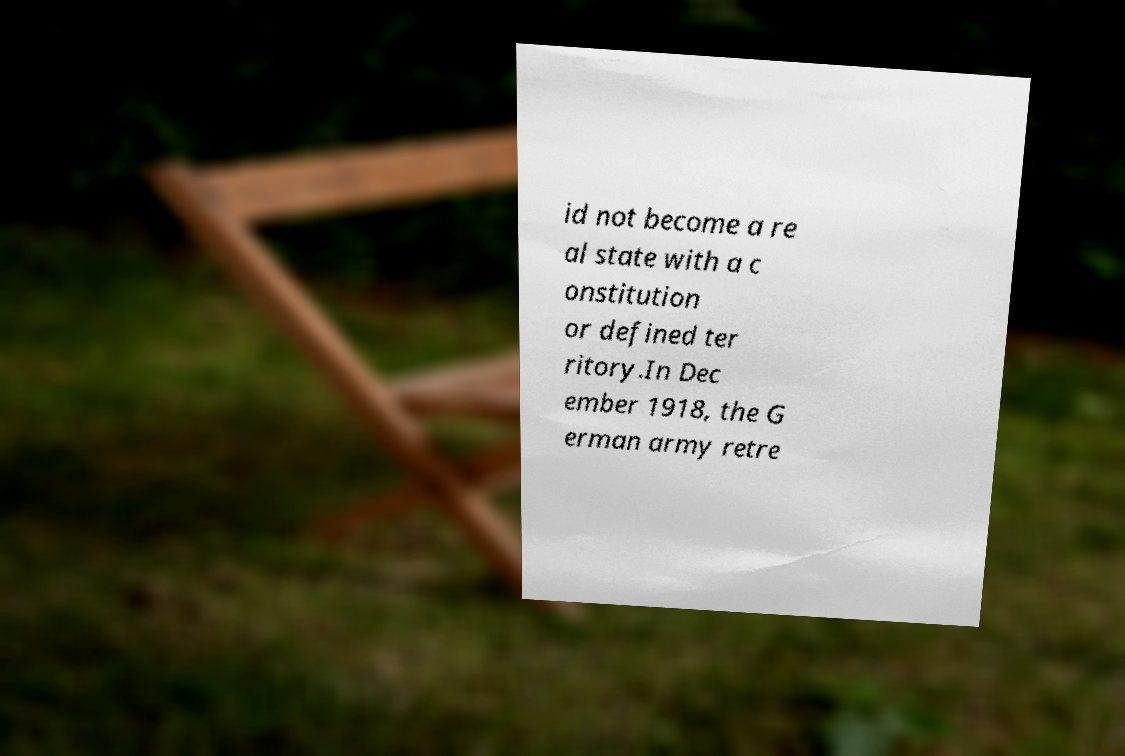Please read and relay the text visible in this image. What does it say? id not become a re al state with a c onstitution or defined ter ritory.In Dec ember 1918, the G erman army retre 